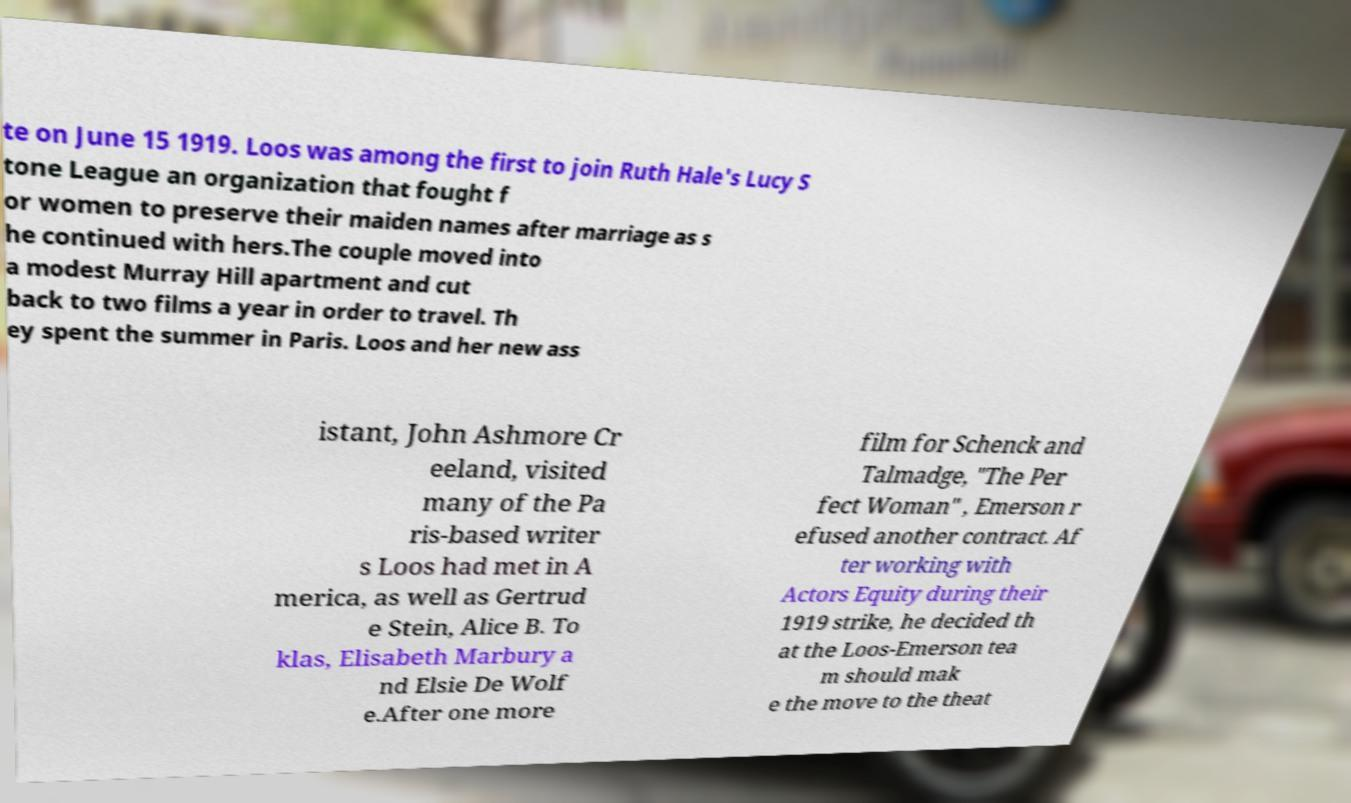I need the written content from this picture converted into text. Can you do that? te on June 15 1919. Loos was among the first to join Ruth Hale's Lucy S tone League an organization that fought f or women to preserve their maiden names after marriage as s he continued with hers.The couple moved into a modest Murray Hill apartment and cut back to two films a year in order to travel. Th ey spent the summer in Paris. Loos and her new ass istant, John Ashmore Cr eeland, visited many of the Pa ris-based writer s Loos had met in A merica, as well as Gertrud e Stein, Alice B. To klas, Elisabeth Marbury a nd Elsie De Wolf e.After one more film for Schenck and Talmadge, "The Per fect Woman" , Emerson r efused another contract. Af ter working with Actors Equity during their 1919 strike, he decided th at the Loos-Emerson tea m should mak e the move to the theat 